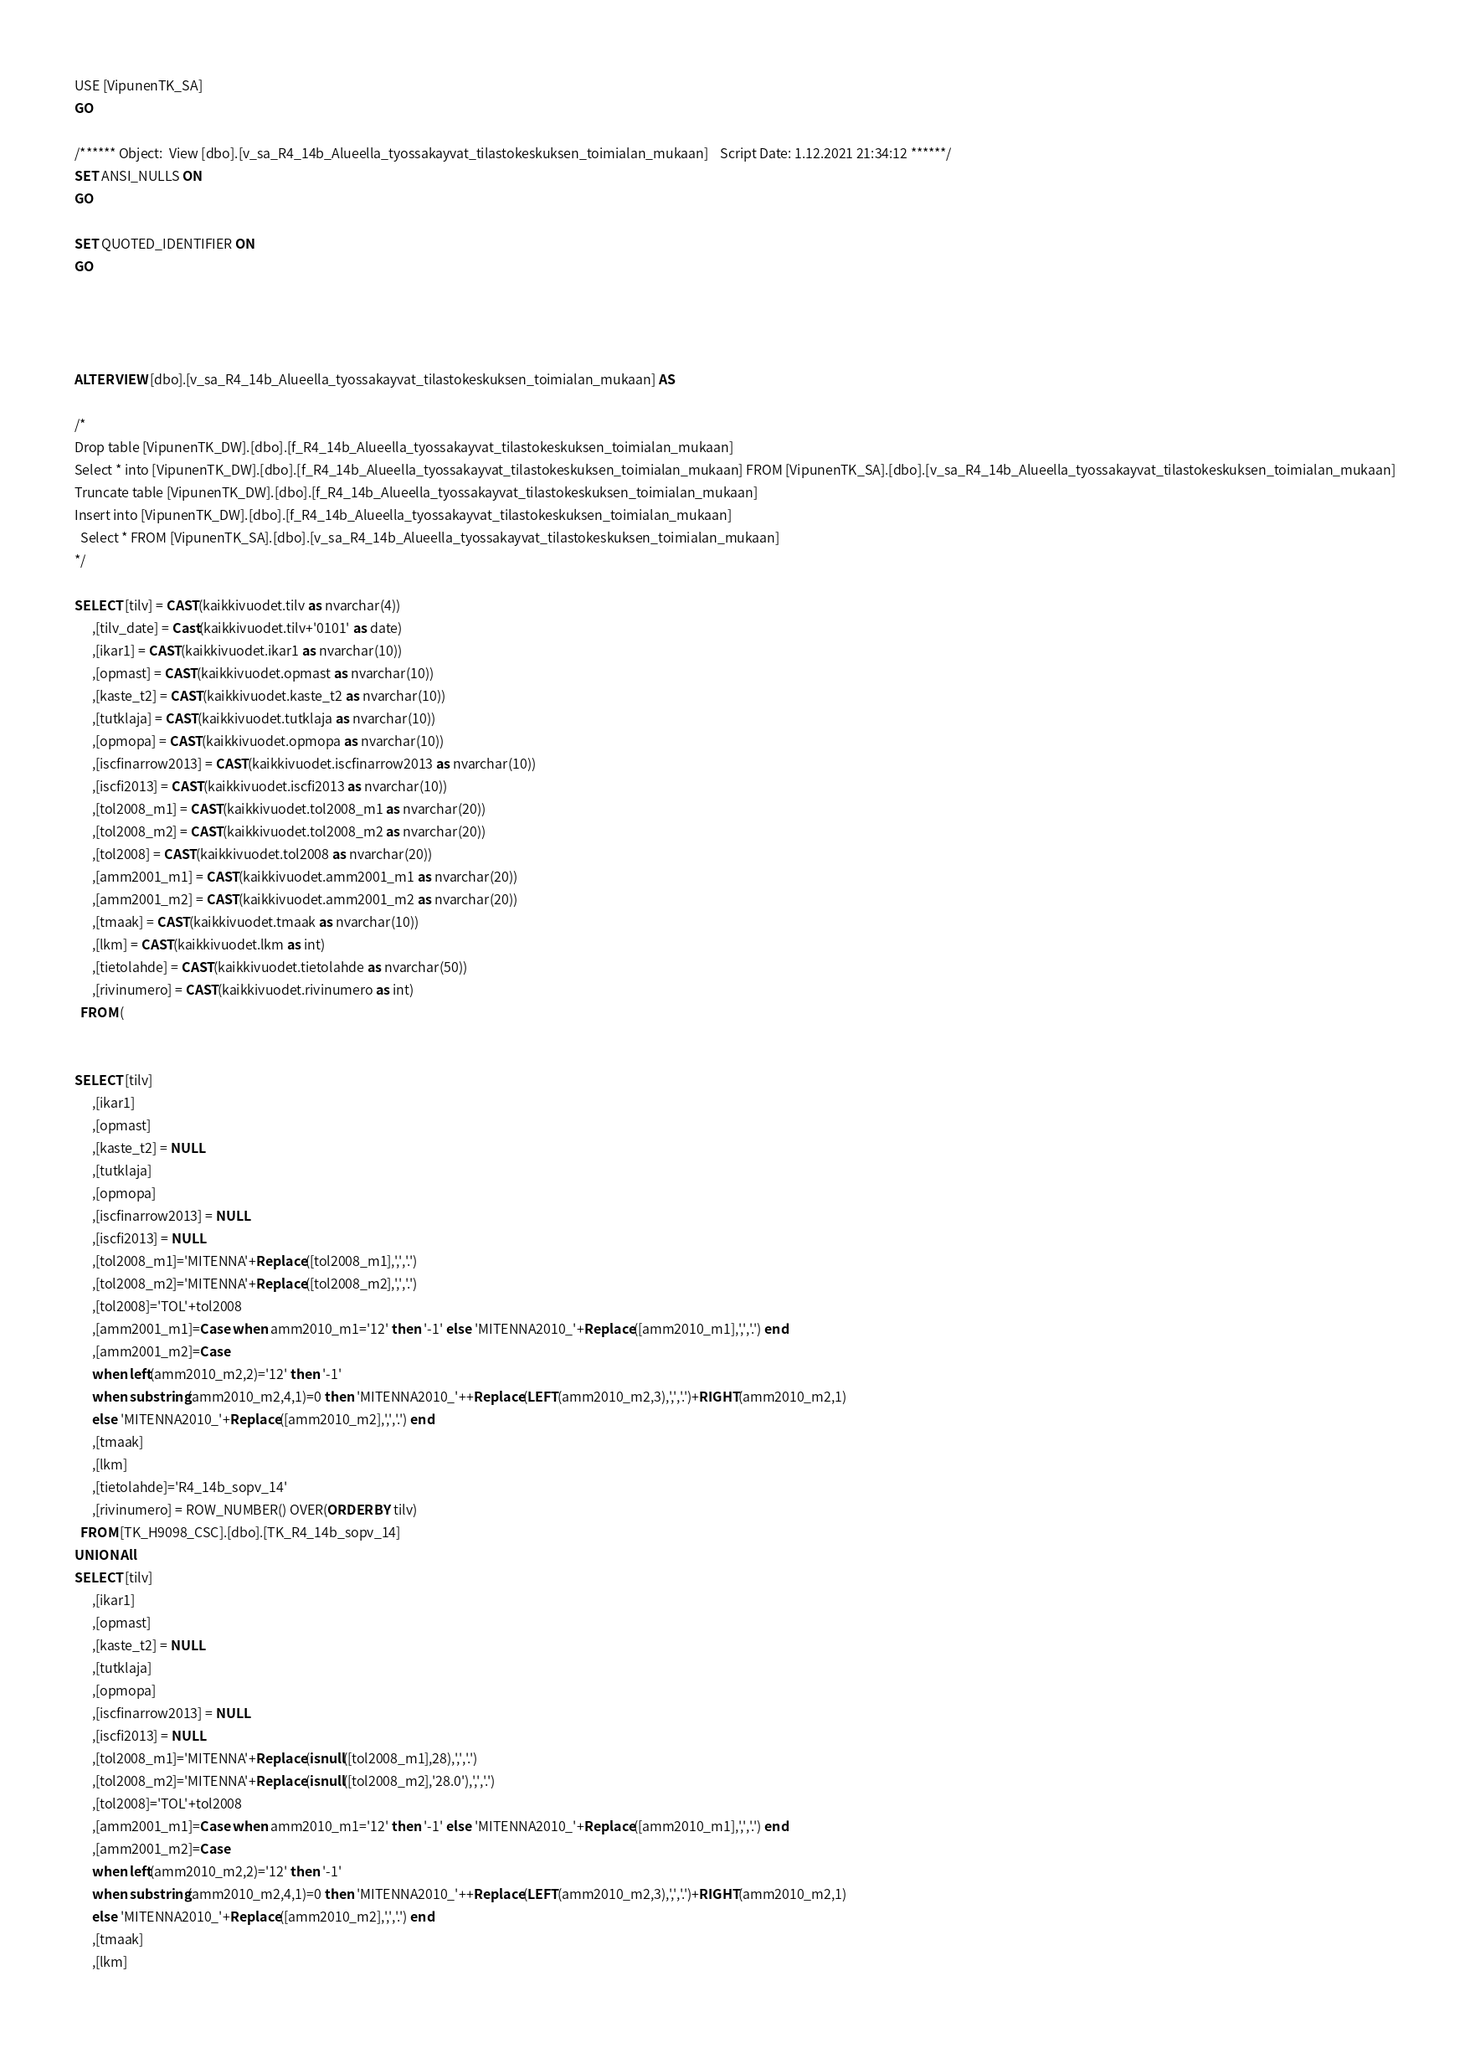Convert code to text. <code><loc_0><loc_0><loc_500><loc_500><_SQL_>USE [VipunenTK_SA]
GO

/****** Object:  View [dbo].[v_sa_R4_14b_Alueella_tyossakayvat_tilastokeskuksen_toimialan_mukaan]    Script Date: 1.12.2021 21:34:12 ******/
SET ANSI_NULLS ON
GO

SET QUOTED_IDENTIFIER ON
GO




ALTER VIEW [dbo].[v_sa_R4_14b_Alueella_tyossakayvat_tilastokeskuksen_toimialan_mukaan] AS

/*
Drop table [VipunenTK_DW].[dbo].[f_R4_14b_Alueella_tyossakayvat_tilastokeskuksen_toimialan_mukaan]
Select * into [VipunenTK_DW].[dbo].[f_R4_14b_Alueella_tyossakayvat_tilastokeskuksen_toimialan_mukaan] FROM [VipunenTK_SA].[dbo].[v_sa_R4_14b_Alueella_tyossakayvat_tilastokeskuksen_toimialan_mukaan]
Truncate table [VipunenTK_DW].[dbo].[f_R4_14b_Alueella_tyossakayvat_tilastokeskuksen_toimialan_mukaan]
Insert into [VipunenTK_DW].[dbo].[f_R4_14b_Alueella_tyossakayvat_tilastokeskuksen_toimialan_mukaan]
  Select * FROM [VipunenTK_SA].[dbo].[v_sa_R4_14b_Alueella_tyossakayvat_tilastokeskuksen_toimialan_mukaan]
*/

SELECT [tilv] = CAST(kaikkivuodet.tilv as nvarchar(4))
	  ,[tilv_date] = Cast(kaikkivuodet.tilv+'0101' as date)
      ,[ikar1] = CAST(kaikkivuodet.ikar1 as nvarchar(10))
      ,[opmast] = CAST(kaikkivuodet.opmast as nvarchar(10))
	  ,[kaste_t2] = CAST(kaikkivuodet.kaste_t2 as nvarchar(10))
      ,[tutklaja] = CAST(kaikkivuodet.tutklaja as nvarchar(10))
      ,[opmopa] = CAST(kaikkivuodet.opmopa as nvarchar(10))
	  ,[iscfinarrow2013] = CAST(kaikkivuodet.iscfinarrow2013 as nvarchar(10))
	  ,[iscfi2013] = CAST(kaikkivuodet.iscfi2013 as nvarchar(10))
      ,[tol2008_m1] = CAST(kaikkivuodet.tol2008_m1 as nvarchar(20))
      ,[tol2008_m2] = CAST(kaikkivuodet.tol2008_m2 as nvarchar(20))
	  ,[tol2008] = CAST(kaikkivuodet.tol2008 as nvarchar(20))
      ,[amm2001_m1] = CAST(kaikkivuodet.amm2001_m1 as nvarchar(20))
      ,[amm2001_m2] = CAST(kaikkivuodet.amm2001_m2 as nvarchar(20))
      ,[tmaak] = CAST(kaikkivuodet.tmaak as nvarchar(10))
      ,[lkm] = CAST(kaikkivuodet.lkm as int)
      ,[tietolahde] = CAST(kaikkivuodet.tietolahde as nvarchar(50))
      ,[rivinumero] = CAST(kaikkivuodet.rivinumero as int)
  FROM (
 

SELECT [tilv]
      ,[ikar1]
      ,[opmast]
	  ,[kaste_t2] = NULL
      ,[tutklaja]
      ,[opmopa]
	  ,[iscfinarrow2013] = NULL
	  ,[iscfi2013] = NULL
      ,[tol2008_m1]='MITENNA'+Replace([tol2008_m1],',','.')
      ,[tol2008_m2]='MITENNA'+Replace([tol2008_m2],',','.')
	  ,[tol2008]='TOL'+tol2008
      ,[amm2001_m1]=Case when amm2010_m1='12' then '-1' else 'MITENNA2010_'+Replace([amm2010_m1],',','.') end
      ,[amm2001_m2]=Case 
	  when left(amm2010_m2,2)='12' then '-1' 
	  when substring(amm2010_m2,4,1)=0 then 'MITENNA2010_'++Replace(LEFT(amm2010_m2,3),',','.')+RIGHT(amm2010_m2,1)
	  else 'MITENNA2010_'+Replace([amm2010_m2],',','.') end 
      ,[tmaak]
      ,[lkm]
      ,[tietolahde]='R4_14b_sopv_14'
	  ,[rivinumero] = ROW_NUMBER() OVER(ORDER BY tilv)
  FROM [TK_H9098_CSC].[dbo].[TK_R4_14b_sopv_14]
UNION All
SELECT [tilv]
      ,[ikar1]
      ,[opmast]
	  ,[kaste_t2] = NULL
      ,[tutklaja]
      ,[opmopa]
	  ,[iscfinarrow2013] = NULL
	  ,[iscfi2013] = NULL
      ,[tol2008_m1]='MITENNA'+Replace(isnull([tol2008_m1],28),',','.')
      ,[tol2008_m2]='MITENNA'+Replace(isnull([tol2008_m2],'28.0'),',','.')
	  ,[tol2008]='TOL'+tol2008
      ,[amm2001_m1]=Case when amm2010_m1='12' then '-1' else 'MITENNA2010_'+Replace([amm2010_m1],',','.') end
      ,[amm2001_m2]=Case 
	  when left(amm2010_m2,2)='12' then '-1' 
	  when substring(amm2010_m2,4,1)=0 then 'MITENNA2010_'++Replace(LEFT(amm2010_m2,3),',','.')+RIGHT(amm2010_m2,1)
	  else 'MITENNA2010_'+Replace([amm2010_m2],',','.') end 
      ,[tmaak]
      ,[lkm]</code> 